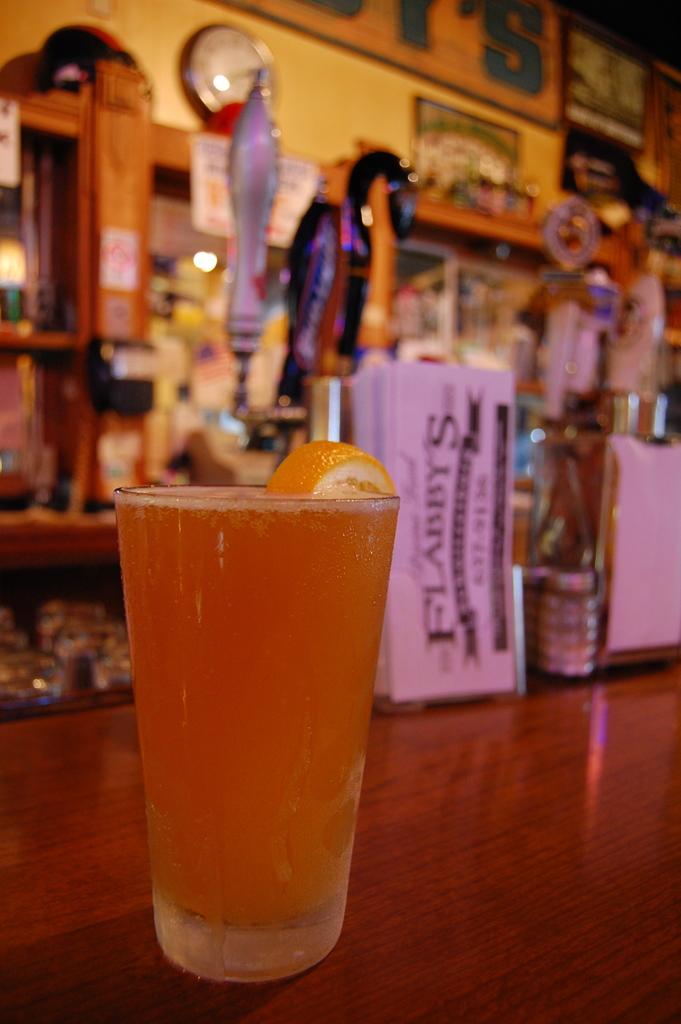What is the name of this bar?
Your answer should be compact. Flabby's. What drink is in the glass?
Keep it short and to the point. Unanswerable. 